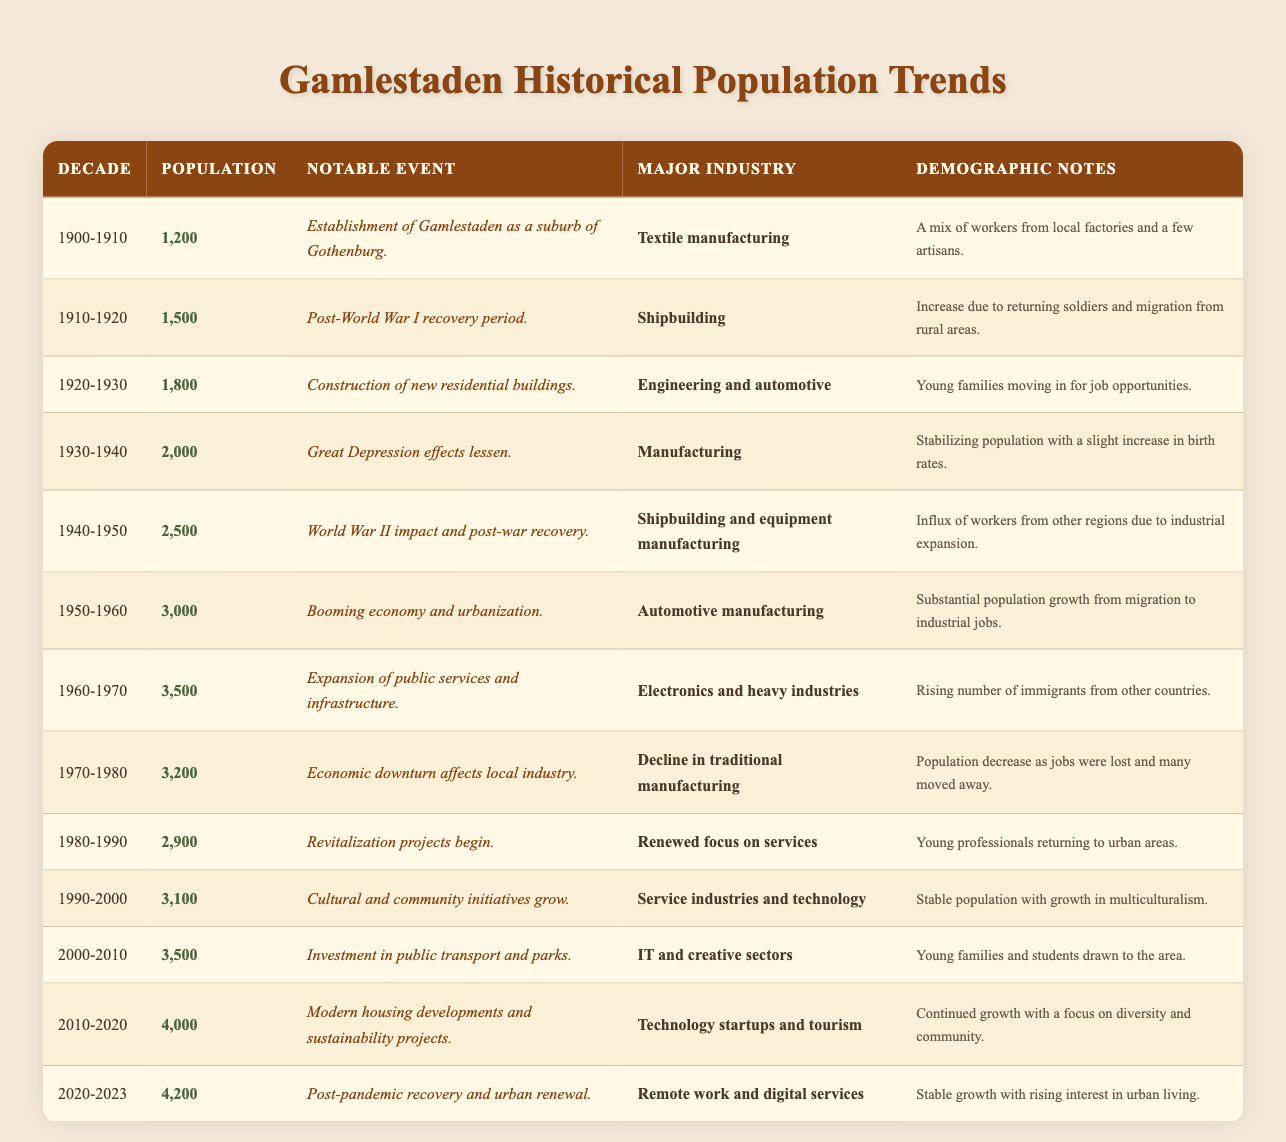What was the population of Gamlestaden in the 1940-1950 decade? The table shows that the population during that decade was recorded as 2,500.
Answer: 2,500 What notable event occurred in the 1910-1920 decade? According to the table, the notable event during this decade was the post-World War I recovery period.
Answer: Post-World War I recovery period What was the major industry in Gamlestaden during the 1960-1970 decade? The major industry listed for that decade is electronics and heavy industries.
Answer: Electronics and heavy industries How many people lived in Gamlestaden during the 1930-1940 decade compared to the 2000-2010 decade? The population in the 1930-1940 decade was 2,000, while in the 2000-2010 decade, it increased to 3,500. The difference is 3,500 - 2,000 = 1,500 more people in the later decade.
Answer: 1,500 Was there a decline in population in the 1970-1980 decade? Yes, the table indicates a population decrease from 3,500 in the 1960-1970 decade to 3,200 in the 1970-1980 decade, confirming a decline.
Answer: Yes What was the average population from 1900-2010? The populations for the decades 1900-2010 are: 1,200, 1,500, 1,800, 2,000, 2,500, 3,000, 3,500, 3,200, 2,900, 3,100, and 3,500. Adding these gives a total of 25,200. There are 11 data points, so the average is 25,200 / 11 ≈ 2,290.91, which can be rounded to 2,291.
Answer: 2,291 What demographic note is associated with the 1980-1990 decade? The demographic notes for this decade state that young professionals were returning to urban areas.
Answer: Young professionals returning to urban areas What was the population in the most recent recorded decade? The table indicates that the population in the 2020-2023 decade was 4,200.
Answer: 4,200 Did the population increase every decade after 1940? No, while there was a general increase, the population decreased from 3,500 in the 1960-1970 decade to 3,200 in the 1970-1980 decade, demonstrating that the increase was not consistent every decade.
Answer: No 